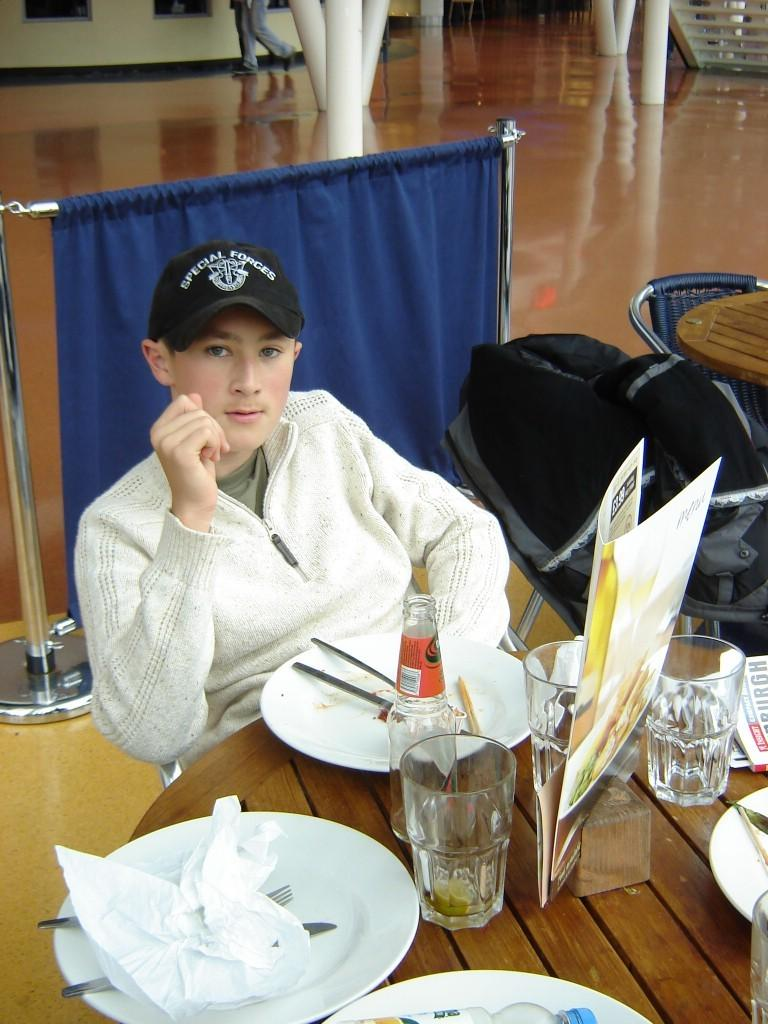Who is present in the image? There is a man in the image. What is the man doing in the image? The man is sitting on a chair. Where is the chair located in relation to the table? The chair is in front of a table. What can be seen on the table in the image? There are glasses and other objects on the table. What month is the scarecrow attempting to predict in the image? There is no scarecrow present in the image, and therefore no prediction of a month can be made. 